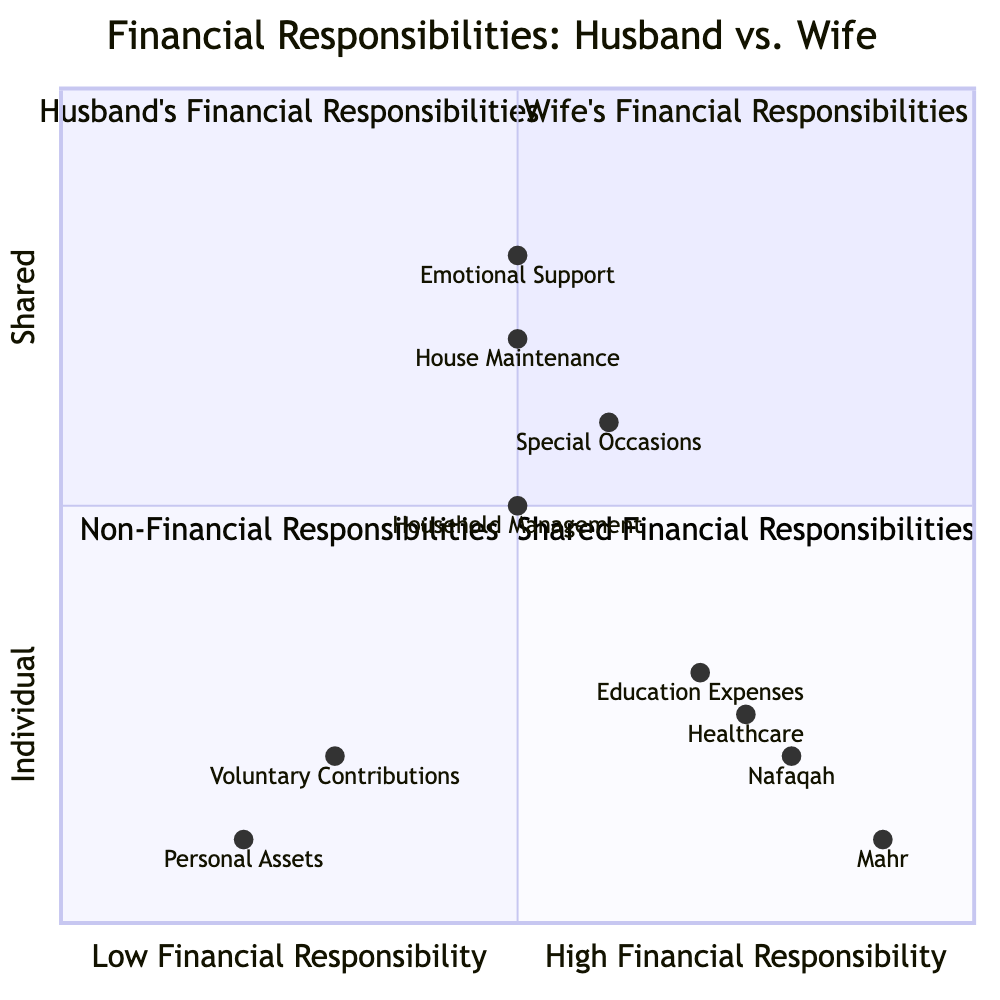What are the two main categories of financial responsibilities depicted in the diagram? The diagram shows two main categories: "Wife's Financial Responsibilities" and "Husband's Financial Responsibilities", both located in their respective quadrants.
Answer: Wife's Financial Responsibilities, Husband's Financial Responsibilities Which financial responsibility is primarily associated with the husband's duty to provide for basic needs? "Nafaqah" is a responsibility that falls under the husband's financial obligations as seen in the quadrant specifically designated for him.
Answer: Nafaqah How many financial responsibilities are assigned to the wife in the diagram? The diagram lists two financial responsibilities specifically designated for the wife, found in her respective quadrant.
Answer: 2 Which responsibility has the highest financial accountability for the husband? "Mahr" has the highest accountability for the husband as depicted in the quadrant showing the husband's financial responsibilities, where it is positioned further to the right on the axis indicating high financial responsibility.
Answer: Mahr In which quadrant are "House Maintenance" and "Special Occasions" responsibilities located? These responsibilities are categorized under "Shared Financial Responsibilities" as indicated by their location in the quadrant designated for shared duties, explaining the collaboration between husband and wife.
Answer: Shared Financial Responsibilities What is the level of financial responsibility for "Emotional Support"? "Emotional Support" is considered a non-financial responsibility, thus falls in the quadrant labeled "Non-Financial Responsibilities," indicating lower financial accountability.
Answer: Non-Financial Responsibilities Is it mandatory for the wife to contribute to family expenses according to the diagram? The diagram specifies that the wife's contribution to family expenses is voluntary, thus indicating it is not a mandatory responsibility.
Answer: Voluntary Which financial obligation requires providing for education expenses for children? "Education Expenses" is the responsibility focused on providing financial support for children's education, clearly articulated in the husband's financial obligations quadrant.
Answer: Education Expenses How can the financial responsibilities be categorized in terms of individual versus shared duties? The financial responsibilities are categorized on an axis indicating individual versus shared duties, with specific responsibilities allocated solely to either the husband or wife, as well as responsibilities shared between them.
Answer: Individual, Shared 